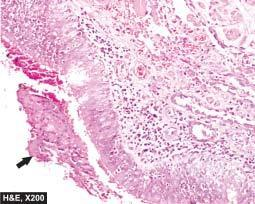what is the mucosa sloughed off at places with?
Answer the question using a single word or phrase. Exudate of muco-pus in lumen 